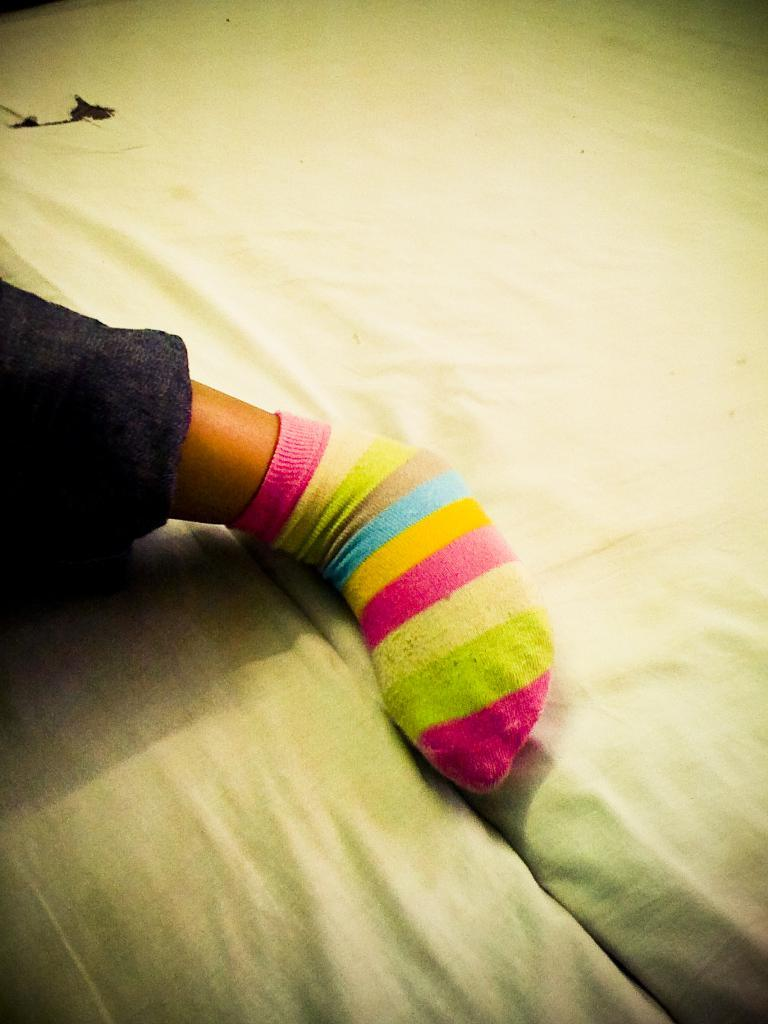What part of a person's body can be seen in the image? There is a person's leg in the image. What type of furniture is visible in the image? There are stocks visible in the image. What color is the bed sheet in the middle of the image? There is a white-colored bed sheet in the middle of the image. What type of statement can be seen written on the bed sheet in the image? There is no statement written on the bed sheet in the image; it is a plain white bed sheet. 